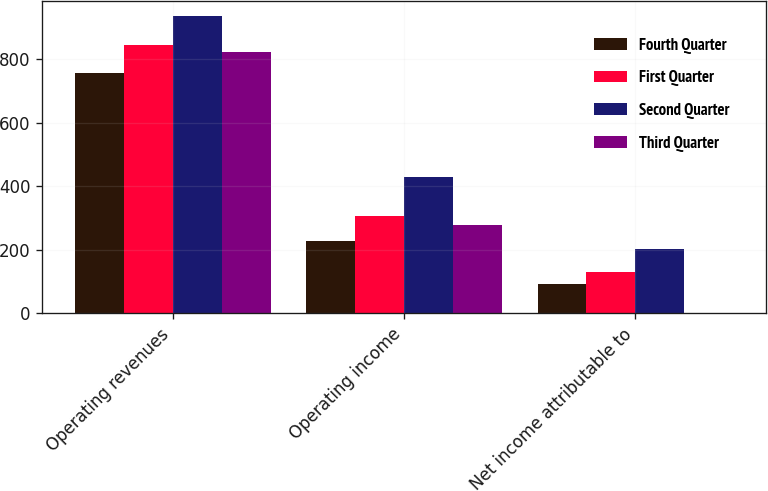Convert chart to OTSL. <chart><loc_0><loc_0><loc_500><loc_500><stacked_bar_chart><ecel><fcel>Operating revenues<fcel>Operating income<fcel>Net income attributable to<nl><fcel>Fourth Quarter<fcel>756<fcel>227<fcel>93<nl><fcel>First Quarter<fcel>844<fcel>308<fcel>131<nl><fcel>Second Quarter<fcel>936<fcel>430<fcel>203<nl><fcel>Third Quarter<fcel>821<fcel>279<fcel>1<nl></chart> 